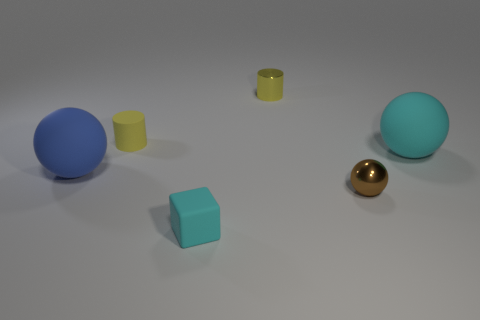Subtract 1 balls. How many balls are left? 2 Add 3 yellow things. How many objects exist? 9 Subtract all cylinders. How many objects are left? 4 Add 2 cyan matte objects. How many cyan matte objects are left? 4 Add 4 large blue shiny cubes. How many large blue shiny cubes exist? 4 Subtract 0 purple blocks. How many objects are left? 6 Subtract all large blue matte spheres. Subtract all blue rubber objects. How many objects are left? 4 